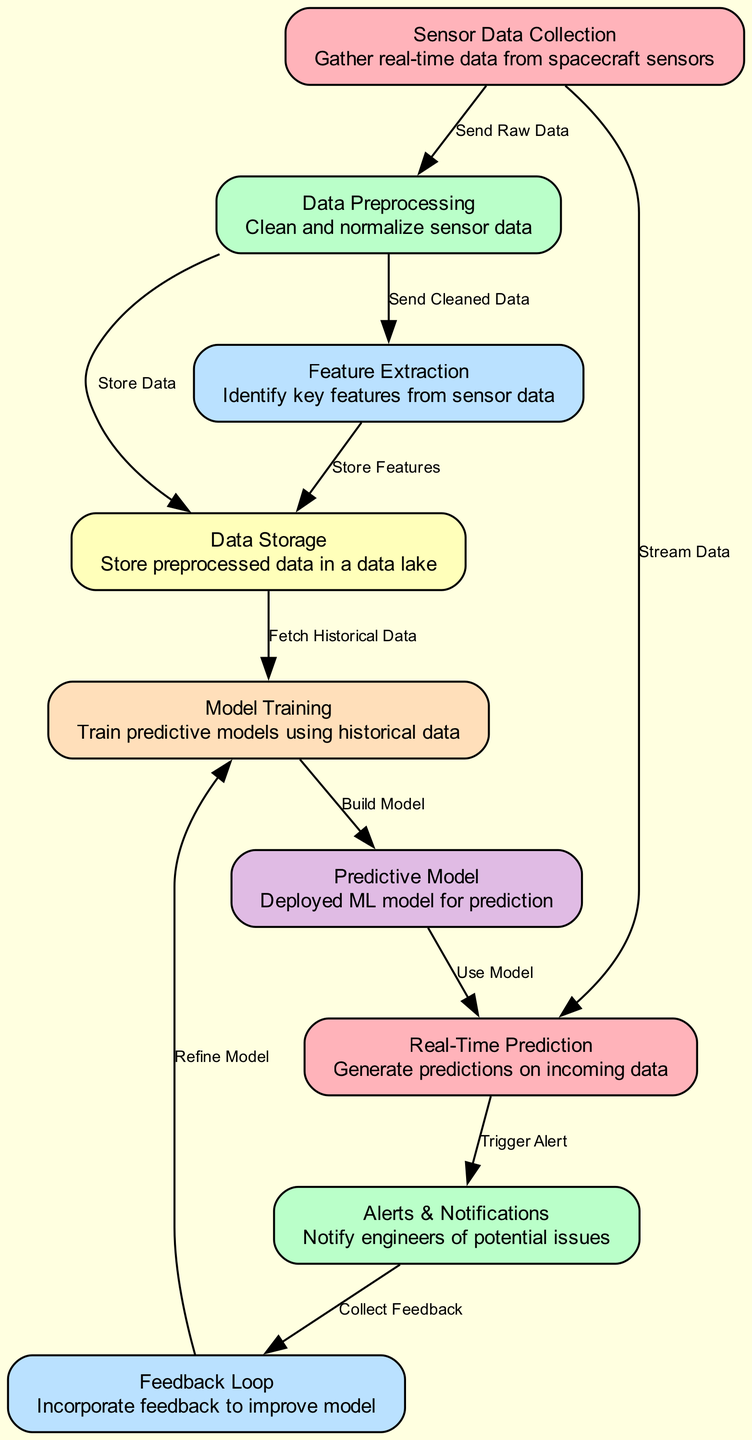What is the first node in the diagram? The diagram starts with the node labeled "Sensor Data Collection," which represents the initial step of gathering real-time data from spacecraft sensors.
Answer: Sensor Data Collection How many nodes are in the diagram? By counting the nodes listed in the data, there are a total of nine distinct nodes, indicating the various stages of the predictive maintenance process.
Answer: Nine What does the edge from "data_preprocessing" to "feature_extraction" signify? This edge indicates that after cleaning the data in the "data_preprocessing" node, the next action is to send that cleaned data to the "feature_extraction" node to identify key features from the sensor data.
Answer: Send Cleaned Data Which node stores the features extracted from the data? The features extracted from the data are stored in the "data_storage" node after being processed in the "feature_extraction" node.
Answer: Data Storage What is the final outcome of the process as illustrated in the diagram? The final outcome of the process is that predictions are generated in the "real_time_prediction" node, which also triggers alerts and notifications if potential issues are detected based on these predictions.
Answer: Real-Time Prediction How does the "feedback_loop" contribute to the model? The "feedback_loop" collects feedback from the "alerts_notifications" node and then incorporates this feedback to refine and improve the model used for predictions, ensuring ongoing accuracy and responsiveness.
Answer: Refine Model What is the relationship between the edges leading to "real_time_prediction"? Two edges lead to "real_time_prediction": one from "sensor_data_collection" indicating that it streams data, and another from "predictive_model" indicating that it uses that model to make real-time predictions on incoming sensor data.
Answer: Stream Data, Use Model What happens when an alert is triggered in the diagram? When an alert is triggered in the "real_time_prediction" node, it results in notifications being sent through the "alerts_notifications" node, ultimately leading to the collection of feedback for the model.
Answer: Collect Feedback 